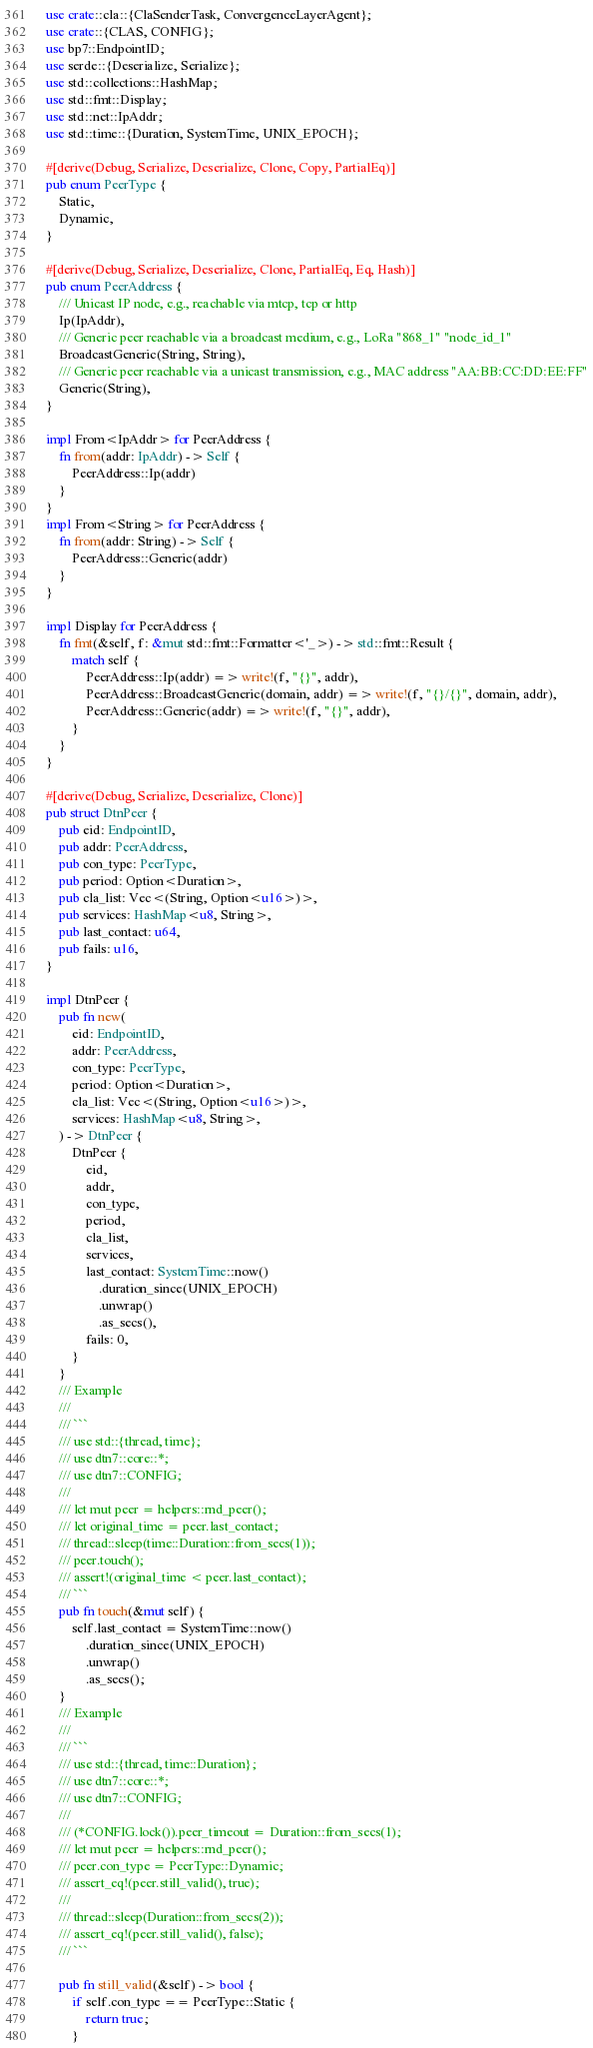Convert code to text. <code><loc_0><loc_0><loc_500><loc_500><_Rust_>use crate::cla::{ClaSenderTask, ConvergenceLayerAgent};
use crate::{CLAS, CONFIG};
use bp7::EndpointID;
use serde::{Deserialize, Serialize};
use std::collections::HashMap;
use std::fmt::Display;
use std::net::IpAddr;
use std::time::{Duration, SystemTime, UNIX_EPOCH};

#[derive(Debug, Serialize, Deserialize, Clone, Copy, PartialEq)]
pub enum PeerType {
    Static,
    Dynamic,
}

#[derive(Debug, Serialize, Deserialize, Clone, PartialEq, Eq, Hash)]
pub enum PeerAddress {
    /// Unicast IP node, e.g., reachable via mtcp, tcp or http
    Ip(IpAddr),
    /// Generic peer reachable via a broadcast medium, e.g., LoRa "868_1" "node_id_1"
    BroadcastGeneric(String, String),
    /// Generic peer reachable via a unicast transmission, e.g., MAC address "AA:BB:CC:DD:EE:FF"
    Generic(String),
}

impl From<IpAddr> for PeerAddress {
    fn from(addr: IpAddr) -> Self {
        PeerAddress::Ip(addr)
    }
}
impl From<String> for PeerAddress {
    fn from(addr: String) -> Self {
        PeerAddress::Generic(addr)
    }
}

impl Display for PeerAddress {
    fn fmt(&self, f: &mut std::fmt::Formatter<'_>) -> std::fmt::Result {
        match self {
            PeerAddress::Ip(addr) => write!(f, "{}", addr),
            PeerAddress::BroadcastGeneric(domain, addr) => write!(f, "{}/{}", domain, addr),
            PeerAddress::Generic(addr) => write!(f, "{}", addr),
        }
    }
}

#[derive(Debug, Serialize, Deserialize, Clone)]
pub struct DtnPeer {
    pub eid: EndpointID,
    pub addr: PeerAddress,
    pub con_type: PeerType,
    pub period: Option<Duration>,
    pub cla_list: Vec<(String, Option<u16>)>,
    pub services: HashMap<u8, String>,
    pub last_contact: u64,
    pub fails: u16,
}

impl DtnPeer {
    pub fn new(
        eid: EndpointID,
        addr: PeerAddress,
        con_type: PeerType,
        period: Option<Duration>,
        cla_list: Vec<(String, Option<u16>)>,
        services: HashMap<u8, String>,
    ) -> DtnPeer {
        DtnPeer {
            eid,
            addr,
            con_type,
            period,
            cla_list,
            services,
            last_contact: SystemTime::now()
                .duration_since(UNIX_EPOCH)
                .unwrap()
                .as_secs(),
            fails: 0,
        }
    }
    /// Example
    ///
    /// ```
    /// use std::{thread, time};
    /// use dtn7::core::*;
    /// use dtn7::CONFIG;
    ///
    /// let mut peer = helpers::rnd_peer();
    /// let original_time = peer.last_contact;
    /// thread::sleep(time::Duration::from_secs(1));
    /// peer.touch();
    /// assert!(original_time < peer.last_contact);
    /// ```
    pub fn touch(&mut self) {
        self.last_contact = SystemTime::now()
            .duration_since(UNIX_EPOCH)
            .unwrap()
            .as_secs();
    }
    /// Example
    ///
    /// ```
    /// use std::{thread, time::Duration};
    /// use dtn7::core::*;
    /// use dtn7::CONFIG;
    ///
    /// (*CONFIG.lock()).peer_timeout = Duration::from_secs(1);
    /// let mut peer = helpers::rnd_peer();
    /// peer.con_type = PeerType::Dynamic;
    /// assert_eq!(peer.still_valid(), true);
    ///
    /// thread::sleep(Duration::from_secs(2));
    /// assert_eq!(peer.still_valid(), false);
    /// ```

    pub fn still_valid(&self) -> bool {
        if self.con_type == PeerType::Static {
            return true;
        }</code> 